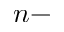<formula> <loc_0><loc_0><loc_500><loc_500>n -</formula> 